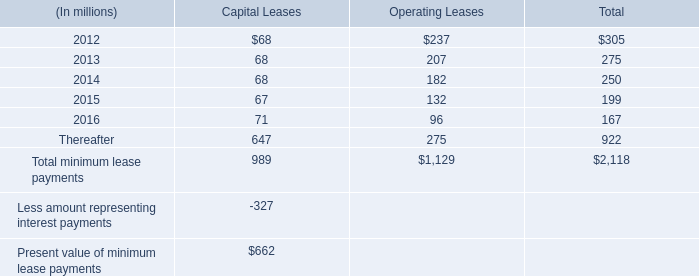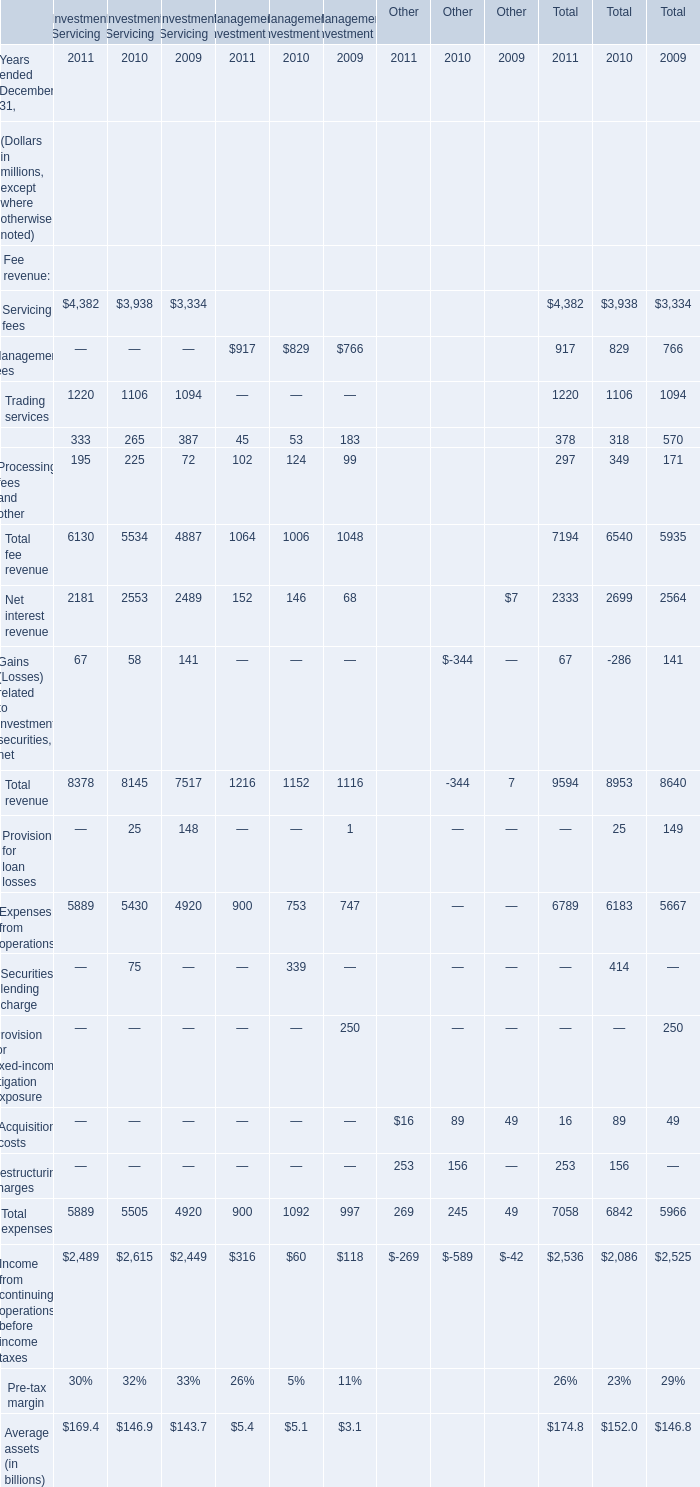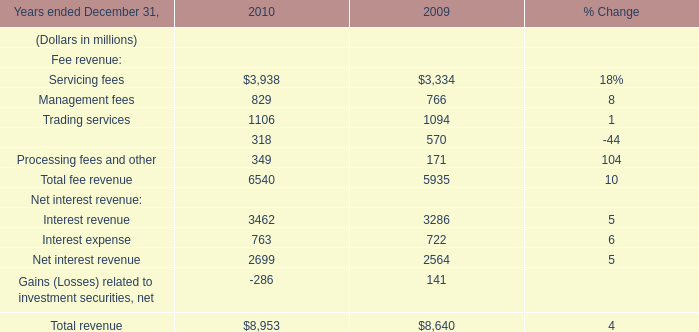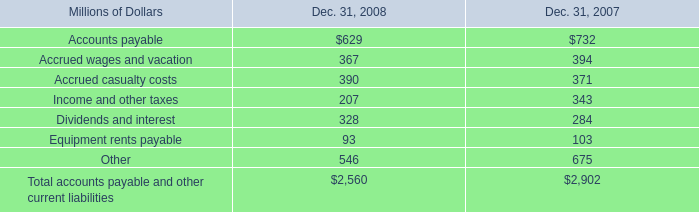What was the total amount of Servicing fees greater than 1 in Investment Servicing (in million) 
Computations: ((4382 + 3938) + 3334)
Answer: 11654.0. 